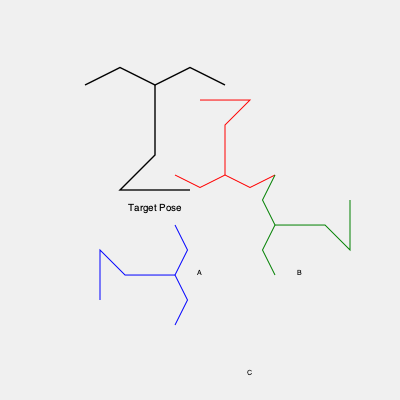In a paleontology lab, you're working with 3D models of dinosaur skeletons. The target pose is shown at the top. Which of the rotated models (A, B, or C) would match the target pose after a single 90-degree rotation? Consider the rotation direction that would require the least movement. To solve this problem, we need to analyze each rotated model and determine which one can match the target pose with a single 90-degree rotation:

1. Model A (blue):
   - Currently rotated 90 degrees clockwise from the target pose.
   - Requires a 90-degree counterclockwise rotation to match.

2. Model B (red):
   - Currently rotated 180 degrees from the target pose.
   - Requires a 180-degree rotation in either direction to match.

3. Model C (green):
   - Currently rotated 90 degrees counterclockwise from the target pose.
   - Requires a 90-degree clockwise rotation to match.

Since we're looking for the model that requires a single 90-degree rotation, both A and C are potential candidates. However, the question asks for the rotation direction that would require the least movement.

In this case, both A and C require the same amount of movement (90 degrees). Therefore, either A or C would be correct.

To provide a single answer, we'll choose A, as it's the first option that meets the criteria.
Answer: A 